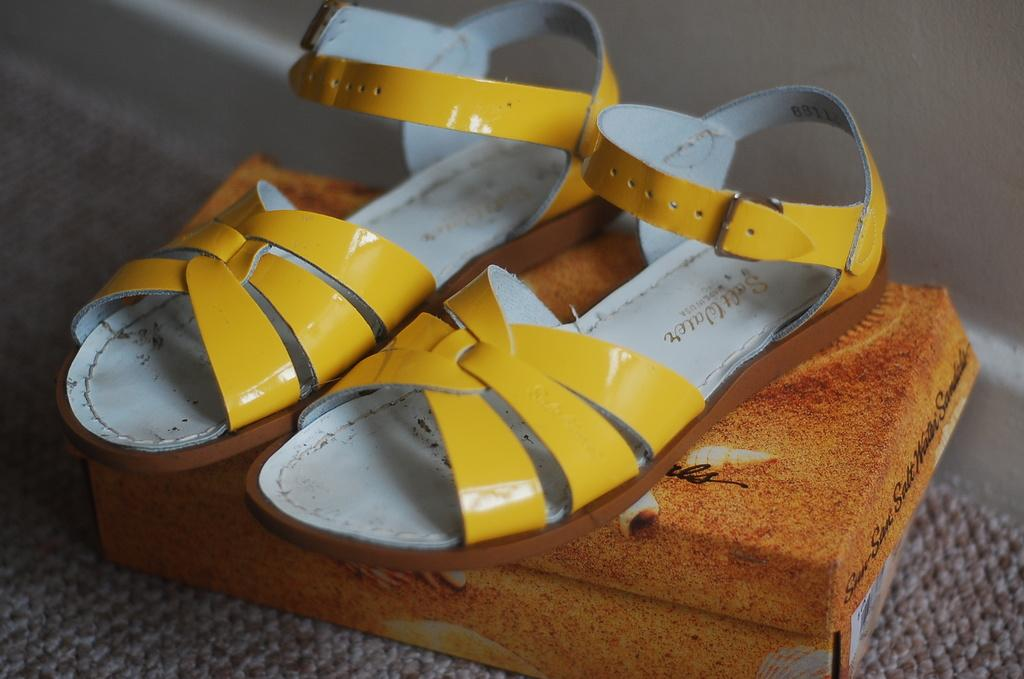What is present on the box in the image? There is footwear in the image, and it is on a box. Where is the box located in the image? The box is in the center of the image. What type of list can be seen on the floor in the image? There is no list present in the image, and the floor is not mentioned in the provided facts. 